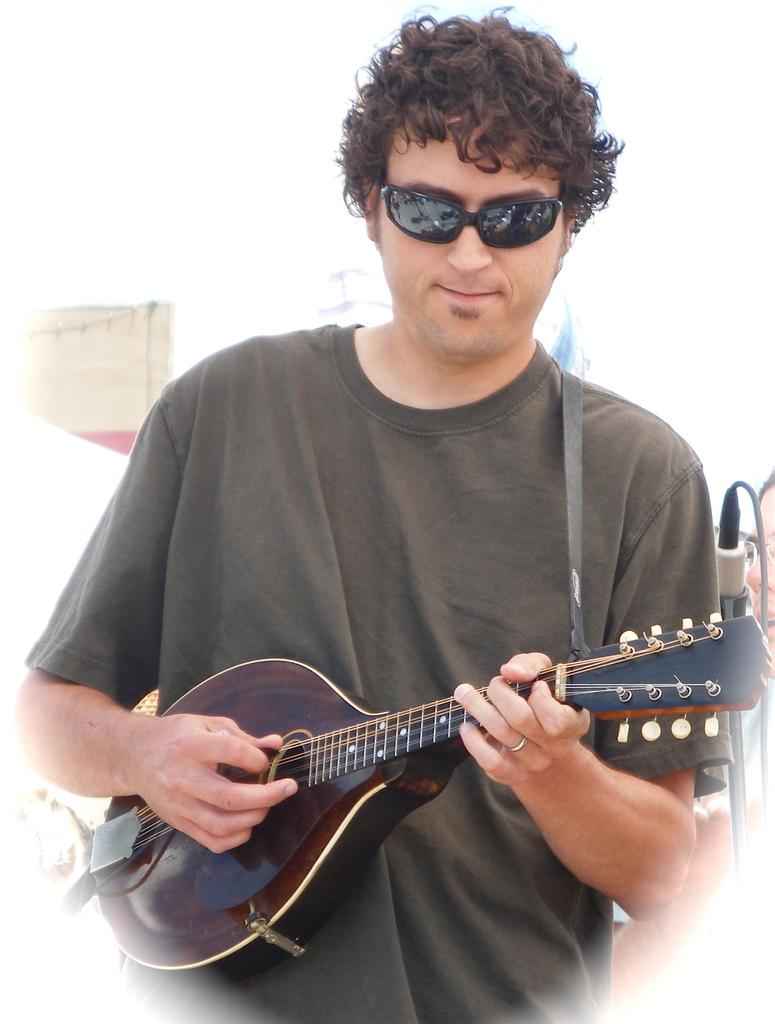What is the man in the image doing? The man is playing a musical instrument. What is the man wearing in the image? The man is wearing a t-shirt. What object is present in the image that is commonly used for amplifying sound? There is a microphone in the image. What type of ice can be seen melting on the man's finger in the image? There is no ice present in the image, and the man's fingers are not shown. 